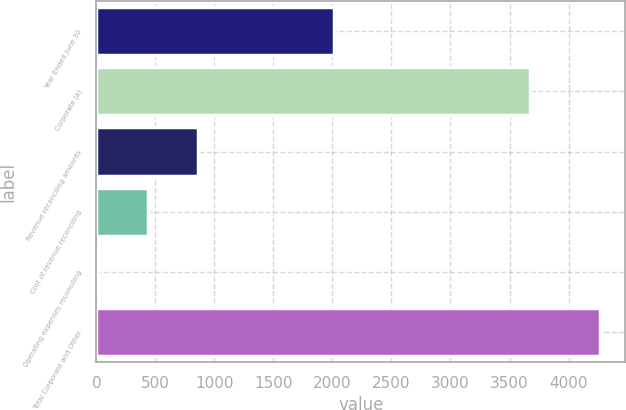Convert chart to OTSL. <chart><loc_0><loc_0><loc_500><loc_500><bar_chart><fcel>Year Ended June 30<fcel>Corporate (a)<fcel>Revenue reconciling amounts<fcel>Cost of revenue reconciling<fcel>Operating expenses reconciling<fcel>Total Corporate and Other<nl><fcel>2012<fcel>3671<fcel>863.6<fcel>438.3<fcel>13<fcel>4266<nl></chart> 